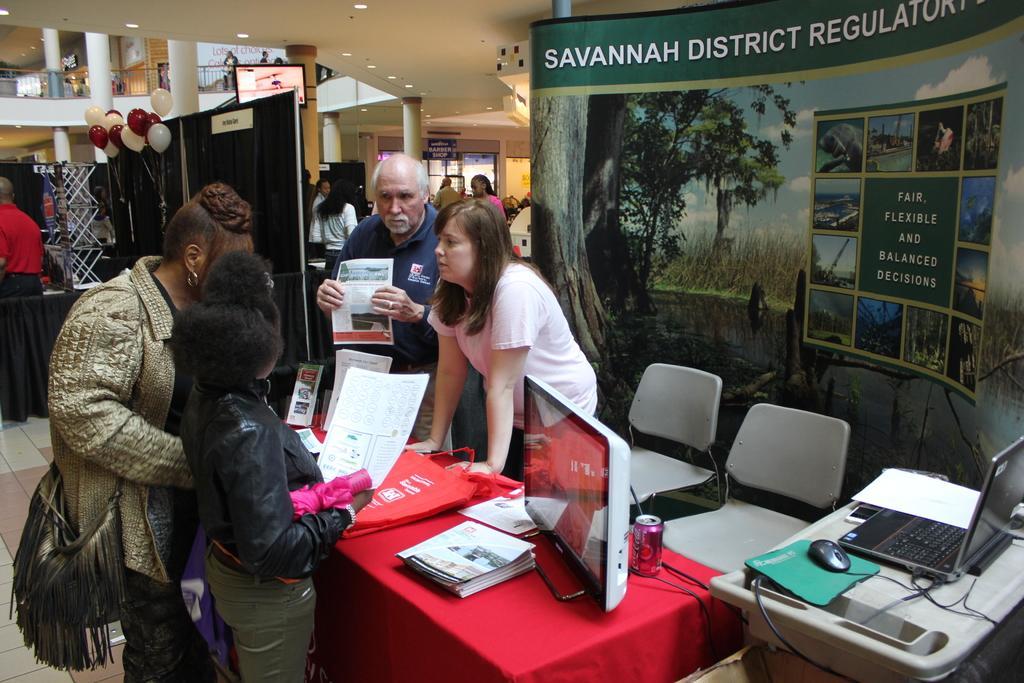Could you give a brief overview of what you see in this image? In this image I can see group of people standing. In front I can see the person is holding few papers and I can also see the laptop and the system and few objects on the table. In the background I can see few boards, balloons in white and red color, the railing, pillars and few lights. 